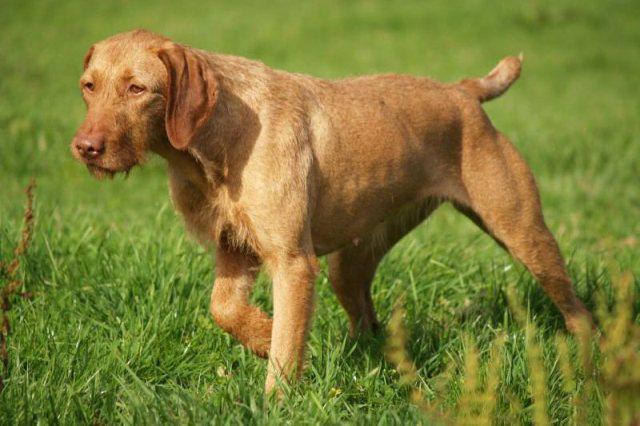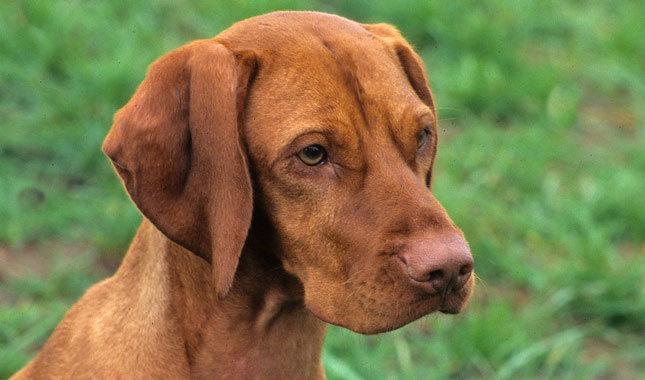The first image is the image on the left, the second image is the image on the right. Assess this claim about the two images: "The dog in each of the images is standing up on all four.". Correct or not? Answer yes or no. No. 